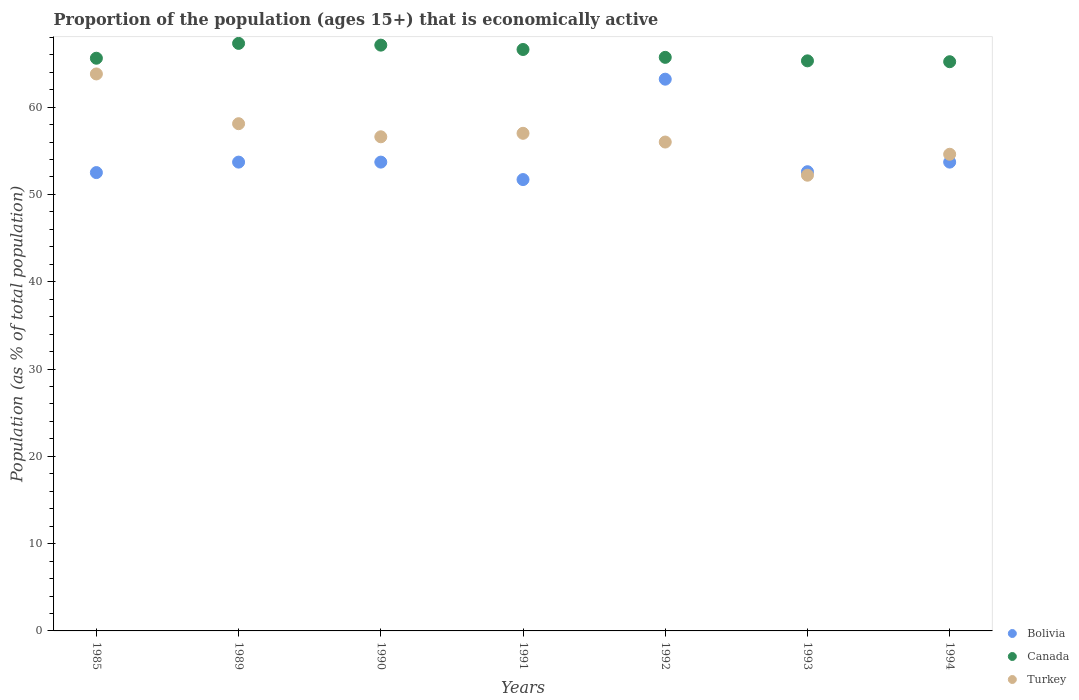Is the number of dotlines equal to the number of legend labels?
Offer a very short reply. Yes. What is the proportion of the population that is economically active in Bolivia in 1985?
Provide a short and direct response. 52.5. Across all years, what is the maximum proportion of the population that is economically active in Turkey?
Provide a short and direct response. 63.8. Across all years, what is the minimum proportion of the population that is economically active in Canada?
Your answer should be very brief. 65.2. In which year was the proportion of the population that is economically active in Canada maximum?
Provide a short and direct response. 1989. What is the total proportion of the population that is economically active in Canada in the graph?
Offer a terse response. 462.8. What is the difference between the proportion of the population that is economically active in Canada in 1985 and that in 1993?
Offer a very short reply. 0.3. What is the difference between the proportion of the population that is economically active in Canada in 1993 and the proportion of the population that is economically active in Turkey in 1985?
Your answer should be very brief. 1.5. What is the average proportion of the population that is economically active in Canada per year?
Your answer should be very brief. 66.11. In the year 1990, what is the difference between the proportion of the population that is economically active in Bolivia and proportion of the population that is economically active in Turkey?
Keep it short and to the point. -2.9. In how many years, is the proportion of the population that is economically active in Canada greater than 22 %?
Keep it short and to the point. 7. What is the ratio of the proportion of the population that is economically active in Turkey in 1992 to that in 1993?
Your response must be concise. 1.07. Is the proportion of the population that is economically active in Canada in 1989 less than that in 1991?
Make the answer very short. No. Is the difference between the proportion of the population that is economically active in Bolivia in 1991 and 1993 greater than the difference between the proportion of the population that is economically active in Turkey in 1991 and 1993?
Make the answer very short. No. What is the difference between the highest and the second highest proportion of the population that is economically active in Turkey?
Offer a terse response. 5.7. What is the difference between the highest and the lowest proportion of the population that is economically active in Turkey?
Offer a very short reply. 11.6. Is the proportion of the population that is economically active in Turkey strictly less than the proportion of the population that is economically active in Bolivia over the years?
Your answer should be compact. No. How many dotlines are there?
Offer a very short reply. 3. How many years are there in the graph?
Your answer should be compact. 7. What is the difference between two consecutive major ticks on the Y-axis?
Provide a short and direct response. 10. Are the values on the major ticks of Y-axis written in scientific E-notation?
Your answer should be compact. No. Does the graph contain grids?
Give a very brief answer. No. Where does the legend appear in the graph?
Your answer should be compact. Bottom right. How are the legend labels stacked?
Provide a short and direct response. Vertical. What is the title of the graph?
Offer a terse response. Proportion of the population (ages 15+) that is economically active. Does "Serbia" appear as one of the legend labels in the graph?
Offer a very short reply. No. What is the label or title of the X-axis?
Give a very brief answer. Years. What is the label or title of the Y-axis?
Keep it short and to the point. Population (as % of total population). What is the Population (as % of total population) of Bolivia in 1985?
Give a very brief answer. 52.5. What is the Population (as % of total population) in Canada in 1985?
Keep it short and to the point. 65.6. What is the Population (as % of total population) of Turkey in 1985?
Give a very brief answer. 63.8. What is the Population (as % of total population) in Bolivia in 1989?
Make the answer very short. 53.7. What is the Population (as % of total population) in Canada in 1989?
Give a very brief answer. 67.3. What is the Population (as % of total population) of Turkey in 1989?
Keep it short and to the point. 58.1. What is the Population (as % of total population) in Bolivia in 1990?
Your response must be concise. 53.7. What is the Population (as % of total population) in Canada in 1990?
Keep it short and to the point. 67.1. What is the Population (as % of total population) of Turkey in 1990?
Offer a terse response. 56.6. What is the Population (as % of total population) in Bolivia in 1991?
Offer a very short reply. 51.7. What is the Population (as % of total population) in Canada in 1991?
Ensure brevity in your answer.  66.6. What is the Population (as % of total population) of Turkey in 1991?
Provide a succinct answer. 57. What is the Population (as % of total population) in Bolivia in 1992?
Provide a succinct answer. 63.2. What is the Population (as % of total population) in Canada in 1992?
Give a very brief answer. 65.7. What is the Population (as % of total population) of Bolivia in 1993?
Provide a short and direct response. 52.6. What is the Population (as % of total population) of Canada in 1993?
Offer a terse response. 65.3. What is the Population (as % of total population) of Turkey in 1993?
Your answer should be compact. 52.2. What is the Population (as % of total population) of Bolivia in 1994?
Your answer should be very brief. 53.7. What is the Population (as % of total population) of Canada in 1994?
Offer a very short reply. 65.2. What is the Population (as % of total population) in Turkey in 1994?
Offer a very short reply. 54.6. Across all years, what is the maximum Population (as % of total population) of Bolivia?
Provide a succinct answer. 63.2. Across all years, what is the maximum Population (as % of total population) in Canada?
Offer a very short reply. 67.3. Across all years, what is the maximum Population (as % of total population) of Turkey?
Keep it short and to the point. 63.8. Across all years, what is the minimum Population (as % of total population) of Bolivia?
Make the answer very short. 51.7. Across all years, what is the minimum Population (as % of total population) of Canada?
Your answer should be compact. 65.2. Across all years, what is the minimum Population (as % of total population) in Turkey?
Keep it short and to the point. 52.2. What is the total Population (as % of total population) of Bolivia in the graph?
Make the answer very short. 381.1. What is the total Population (as % of total population) of Canada in the graph?
Your answer should be compact. 462.8. What is the total Population (as % of total population) in Turkey in the graph?
Your answer should be very brief. 398.3. What is the difference between the Population (as % of total population) in Turkey in 1985 and that in 1989?
Keep it short and to the point. 5.7. What is the difference between the Population (as % of total population) in Canada in 1985 and that in 1990?
Give a very brief answer. -1.5. What is the difference between the Population (as % of total population) in Canada in 1985 and that in 1991?
Your response must be concise. -1. What is the difference between the Population (as % of total population) of Bolivia in 1985 and that in 1992?
Offer a terse response. -10.7. What is the difference between the Population (as % of total population) in Canada in 1985 and that in 1992?
Your answer should be very brief. -0.1. What is the difference between the Population (as % of total population) in Canada in 1985 and that in 1993?
Your answer should be very brief. 0.3. What is the difference between the Population (as % of total population) of Bolivia in 1985 and that in 1994?
Keep it short and to the point. -1.2. What is the difference between the Population (as % of total population) in Turkey in 1989 and that in 1990?
Your answer should be very brief. 1.5. What is the difference between the Population (as % of total population) of Turkey in 1989 and that in 1991?
Your answer should be compact. 1.1. What is the difference between the Population (as % of total population) in Canada in 1989 and that in 1992?
Give a very brief answer. 1.6. What is the difference between the Population (as % of total population) of Canada in 1989 and that in 1993?
Your answer should be compact. 2. What is the difference between the Population (as % of total population) in Bolivia in 1989 and that in 1994?
Your response must be concise. 0. What is the difference between the Population (as % of total population) in Canada in 1990 and that in 1991?
Offer a very short reply. 0.5. What is the difference between the Population (as % of total population) in Turkey in 1990 and that in 1991?
Your answer should be very brief. -0.4. What is the difference between the Population (as % of total population) in Turkey in 1990 and that in 1992?
Offer a terse response. 0.6. What is the difference between the Population (as % of total population) of Turkey in 1990 and that in 1993?
Keep it short and to the point. 4.4. What is the difference between the Population (as % of total population) in Turkey in 1990 and that in 1994?
Give a very brief answer. 2. What is the difference between the Population (as % of total population) of Canada in 1991 and that in 1992?
Your response must be concise. 0.9. What is the difference between the Population (as % of total population) of Turkey in 1991 and that in 1992?
Your answer should be compact. 1. What is the difference between the Population (as % of total population) in Bolivia in 1991 and that in 1993?
Your answer should be very brief. -0.9. What is the difference between the Population (as % of total population) of Canada in 1991 and that in 1993?
Make the answer very short. 1.3. What is the difference between the Population (as % of total population) of Turkey in 1991 and that in 1993?
Your answer should be compact. 4.8. What is the difference between the Population (as % of total population) of Bolivia in 1991 and that in 1994?
Offer a very short reply. -2. What is the difference between the Population (as % of total population) in Canada in 1991 and that in 1994?
Keep it short and to the point. 1.4. What is the difference between the Population (as % of total population) of Canada in 1992 and that in 1993?
Your answer should be compact. 0.4. What is the difference between the Population (as % of total population) in Turkey in 1992 and that in 1994?
Provide a succinct answer. 1.4. What is the difference between the Population (as % of total population) of Turkey in 1993 and that in 1994?
Offer a terse response. -2.4. What is the difference between the Population (as % of total population) of Bolivia in 1985 and the Population (as % of total population) of Canada in 1989?
Provide a succinct answer. -14.8. What is the difference between the Population (as % of total population) of Bolivia in 1985 and the Population (as % of total population) of Canada in 1990?
Give a very brief answer. -14.6. What is the difference between the Population (as % of total population) of Canada in 1985 and the Population (as % of total population) of Turkey in 1990?
Make the answer very short. 9. What is the difference between the Population (as % of total population) in Bolivia in 1985 and the Population (as % of total population) in Canada in 1991?
Your answer should be very brief. -14.1. What is the difference between the Population (as % of total population) of Bolivia in 1985 and the Population (as % of total population) of Turkey in 1991?
Offer a terse response. -4.5. What is the difference between the Population (as % of total population) in Bolivia in 1985 and the Population (as % of total population) in Canada in 1992?
Make the answer very short. -13.2. What is the difference between the Population (as % of total population) of Canada in 1985 and the Population (as % of total population) of Turkey in 1992?
Ensure brevity in your answer.  9.6. What is the difference between the Population (as % of total population) of Canada in 1985 and the Population (as % of total population) of Turkey in 1993?
Make the answer very short. 13.4. What is the difference between the Population (as % of total population) of Bolivia in 1985 and the Population (as % of total population) of Canada in 1994?
Offer a terse response. -12.7. What is the difference between the Population (as % of total population) in Bolivia in 1985 and the Population (as % of total population) in Turkey in 1994?
Provide a short and direct response. -2.1. What is the difference between the Population (as % of total population) in Canada in 1985 and the Population (as % of total population) in Turkey in 1994?
Provide a succinct answer. 11. What is the difference between the Population (as % of total population) in Bolivia in 1989 and the Population (as % of total population) in Turkey in 1991?
Make the answer very short. -3.3. What is the difference between the Population (as % of total population) in Canada in 1989 and the Population (as % of total population) in Turkey in 1991?
Make the answer very short. 10.3. What is the difference between the Population (as % of total population) in Bolivia in 1989 and the Population (as % of total population) in Canada in 1992?
Make the answer very short. -12. What is the difference between the Population (as % of total population) of Canada in 1989 and the Population (as % of total population) of Turkey in 1992?
Your answer should be very brief. 11.3. What is the difference between the Population (as % of total population) in Bolivia in 1989 and the Population (as % of total population) in Canada in 1993?
Make the answer very short. -11.6. What is the difference between the Population (as % of total population) of Bolivia in 1989 and the Population (as % of total population) of Turkey in 1993?
Offer a terse response. 1.5. What is the difference between the Population (as % of total population) of Bolivia in 1989 and the Population (as % of total population) of Turkey in 1994?
Your answer should be compact. -0.9. What is the difference between the Population (as % of total population) of Canada in 1989 and the Population (as % of total population) of Turkey in 1994?
Ensure brevity in your answer.  12.7. What is the difference between the Population (as % of total population) of Bolivia in 1990 and the Population (as % of total population) of Canada in 1991?
Your response must be concise. -12.9. What is the difference between the Population (as % of total population) in Bolivia in 1990 and the Population (as % of total population) in Turkey in 1991?
Your answer should be compact. -3.3. What is the difference between the Population (as % of total population) of Bolivia in 1990 and the Population (as % of total population) of Canada in 1992?
Offer a very short reply. -12. What is the difference between the Population (as % of total population) in Bolivia in 1990 and the Population (as % of total population) in Turkey in 1992?
Keep it short and to the point. -2.3. What is the difference between the Population (as % of total population) of Canada in 1990 and the Population (as % of total population) of Turkey in 1992?
Offer a very short reply. 11.1. What is the difference between the Population (as % of total population) in Bolivia in 1990 and the Population (as % of total population) in Turkey in 1993?
Make the answer very short. 1.5. What is the difference between the Population (as % of total population) in Bolivia in 1990 and the Population (as % of total population) in Canada in 1994?
Ensure brevity in your answer.  -11.5. What is the difference between the Population (as % of total population) of Bolivia in 1990 and the Population (as % of total population) of Turkey in 1994?
Offer a very short reply. -0.9. What is the difference between the Population (as % of total population) in Bolivia in 1991 and the Population (as % of total population) in Canada in 1993?
Ensure brevity in your answer.  -13.6. What is the difference between the Population (as % of total population) in Canada in 1991 and the Population (as % of total population) in Turkey in 1993?
Make the answer very short. 14.4. What is the difference between the Population (as % of total population) in Bolivia in 1991 and the Population (as % of total population) in Canada in 1994?
Provide a succinct answer. -13.5. What is the difference between the Population (as % of total population) in Canada in 1991 and the Population (as % of total population) in Turkey in 1994?
Offer a terse response. 12. What is the difference between the Population (as % of total population) of Bolivia in 1992 and the Population (as % of total population) of Turkey in 1993?
Offer a terse response. 11. What is the difference between the Population (as % of total population) of Canada in 1992 and the Population (as % of total population) of Turkey in 1993?
Make the answer very short. 13.5. What is the difference between the Population (as % of total population) in Bolivia in 1992 and the Population (as % of total population) in Canada in 1994?
Offer a very short reply. -2. What is the difference between the Population (as % of total population) of Bolivia in 1992 and the Population (as % of total population) of Turkey in 1994?
Keep it short and to the point. 8.6. What is the difference between the Population (as % of total population) in Canada in 1992 and the Population (as % of total population) in Turkey in 1994?
Offer a very short reply. 11.1. What is the average Population (as % of total population) in Bolivia per year?
Provide a succinct answer. 54.44. What is the average Population (as % of total population) of Canada per year?
Offer a very short reply. 66.11. What is the average Population (as % of total population) in Turkey per year?
Make the answer very short. 56.9. In the year 1985, what is the difference between the Population (as % of total population) of Bolivia and Population (as % of total population) of Canada?
Provide a succinct answer. -13.1. In the year 1985, what is the difference between the Population (as % of total population) in Bolivia and Population (as % of total population) in Turkey?
Provide a succinct answer. -11.3. In the year 1985, what is the difference between the Population (as % of total population) of Canada and Population (as % of total population) of Turkey?
Your response must be concise. 1.8. In the year 1989, what is the difference between the Population (as % of total population) in Bolivia and Population (as % of total population) in Turkey?
Your answer should be very brief. -4.4. In the year 1990, what is the difference between the Population (as % of total population) of Bolivia and Population (as % of total population) of Canada?
Provide a succinct answer. -13.4. In the year 1990, what is the difference between the Population (as % of total population) in Bolivia and Population (as % of total population) in Turkey?
Keep it short and to the point. -2.9. In the year 1991, what is the difference between the Population (as % of total population) of Bolivia and Population (as % of total population) of Canada?
Offer a terse response. -14.9. In the year 1992, what is the difference between the Population (as % of total population) of Bolivia and Population (as % of total population) of Canada?
Keep it short and to the point. -2.5. In the year 1993, what is the difference between the Population (as % of total population) in Bolivia and Population (as % of total population) in Canada?
Provide a short and direct response. -12.7. In the year 1993, what is the difference between the Population (as % of total population) of Canada and Population (as % of total population) of Turkey?
Your answer should be very brief. 13.1. In the year 1994, what is the difference between the Population (as % of total population) in Bolivia and Population (as % of total population) in Canada?
Your answer should be very brief. -11.5. What is the ratio of the Population (as % of total population) of Bolivia in 1985 to that in 1989?
Your answer should be compact. 0.98. What is the ratio of the Population (as % of total population) in Canada in 1985 to that in 1989?
Provide a short and direct response. 0.97. What is the ratio of the Population (as % of total population) of Turkey in 1985 to that in 1989?
Keep it short and to the point. 1.1. What is the ratio of the Population (as % of total population) in Bolivia in 1985 to that in 1990?
Your answer should be compact. 0.98. What is the ratio of the Population (as % of total population) of Canada in 1985 to that in 1990?
Make the answer very short. 0.98. What is the ratio of the Population (as % of total population) in Turkey in 1985 to that in 1990?
Provide a short and direct response. 1.13. What is the ratio of the Population (as % of total population) in Bolivia in 1985 to that in 1991?
Keep it short and to the point. 1.02. What is the ratio of the Population (as % of total population) of Canada in 1985 to that in 1991?
Make the answer very short. 0.98. What is the ratio of the Population (as % of total population) in Turkey in 1985 to that in 1991?
Provide a short and direct response. 1.12. What is the ratio of the Population (as % of total population) in Bolivia in 1985 to that in 1992?
Give a very brief answer. 0.83. What is the ratio of the Population (as % of total population) of Turkey in 1985 to that in 1992?
Offer a very short reply. 1.14. What is the ratio of the Population (as % of total population) in Bolivia in 1985 to that in 1993?
Your response must be concise. 1. What is the ratio of the Population (as % of total population) in Turkey in 1985 to that in 1993?
Provide a succinct answer. 1.22. What is the ratio of the Population (as % of total population) in Bolivia in 1985 to that in 1994?
Give a very brief answer. 0.98. What is the ratio of the Population (as % of total population) of Turkey in 1985 to that in 1994?
Offer a very short reply. 1.17. What is the ratio of the Population (as % of total population) of Bolivia in 1989 to that in 1990?
Offer a terse response. 1. What is the ratio of the Population (as % of total population) of Canada in 1989 to that in 1990?
Ensure brevity in your answer.  1. What is the ratio of the Population (as % of total population) in Turkey in 1989 to that in 1990?
Your response must be concise. 1.03. What is the ratio of the Population (as % of total population) in Bolivia in 1989 to that in 1991?
Ensure brevity in your answer.  1.04. What is the ratio of the Population (as % of total population) of Canada in 1989 to that in 1991?
Your response must be concise. 1.01. What is the ratio of the Population (as % of total population) in Turkey in 1989 to that in 1991?
Provide a short and direct response. 1.02. What is the ratio of the Population (as % of total population) in Bolivia in 1989 to that in 1992?
Your response must be concise. 0.85. What is the ratio of the Population (as % of total population) in Canada in 1989 to that in 1992?
Ensure brevity in your answer.  1.02. What is the ratio of the Population (as % of total population) in Turkey in 1989 to that in 1992?
Your answer should be compact. 1.04. What is the ratio of the Population (as % of total population) of Bolivia in 1989 to that in 1993?
Your answer should be very brief. 1.02. What is the ratio of the Population (as % of total population) in Canada in 1989 to that in 1993?
Your response must be concise. 1.03. What is the ratio of the Population (as % of total population) of Turkey in 1989 to that in 1993?
Offer a terse response. 1.11. What is the ratio of the Population (as % of total population) in Bolivia in 1989 to that in 1994?
Your answer should be compact. 1. What is the ratio of the Population (as % of total population) in Canada in 1989 to that in 1994?
Your response must be concise. 1.03. What is the ratio of the Population (as % of total population) in Turkey in 1989 to that in 1994?
Your response must be concise. 1.06. What is the ratio of the Population (as % of total population) in Bolivia in 1990 to that in 1991?
Offer a terse response. 1.04. What is the ratio of the Population (as % of total population) in Canada in 1990 to that in 1991?
Provide a short and direct response. 1.01. What is the ratio of the Population (as % of total population) of Turkey in 1990 to that in 1991?
Keep it short and to the point. 0.99. What is the ratio of the Population (as % of total population) in Bolivia in 1990 to that in 1992?
Your answer should be compact. 0.85. What is the ratio of the Population (as % of total population) of Canada in 1990 to that in 1992?
Your answer should be very brief. 1.02. What is the ratio of the Population (as % of total population) in Turkey in 1990 to that in 1992?
Your answer should be very brief. 1.01. What is the ratio of the Population (as % of total population) in Bolivia in 1990 to that in 1993?
Your answer should be compact. 1.02. What is the ratio of the Population (as % of total population) of Canada in 1990 to that in 1993?
Provide a succinct answer. 1.03. What is the ratio of the Population (as % of total population) in Turkey in 1990 to that in 1993?
Offer a terse response. 1.08. What is the ratio of the Population (as % of total population) of Bolivia in 1990 to that in 1994?
Offer a terse response. 1. What is the ratio of the Population (as % of total population) of Canada in 1990 to that in 1994?
Make the answer very short. 1.03. What is the ratio of the Population (as % of total population) of Turkey in 1990 to that in 1994?
Provide a short and direct response. 1.04. What is the ratio of the Population (as % of total population) in Bolivia in 1991 to that in 1992?
Keep it short and to the point. 0.82. What is the ratio of the Population (as % of total population) in Canada in 1991 to that in 1992?
Provide a short and direct response. 1.01. What is the ratio of the Population (as % of total population) of Turkey in 1991 to that in 1992?
Offer a very short reply. 1.02. What is the ratio of the Population (as % of total population) of Bolivia in 1991 to that in 1993?
Make the answer very short. 0.98. What is the ratio of the Population (as % of total population) in Canada in 1991 to that in 1993?
Keep it short and to the point. 1.02. What is the ratio of the Population (as % of total population) of Turkey in 1991 to that in 1993?
Offer a very short reply. 1.09. What is the ratio of the Population (as % of total population) in Bolivia in 1991 to that in 1994?
Offer a terse response. 0.96. What is the ratio of the Population (as % of total population) in Canada in 1991 to that in 1994?
Make the answer very short. 1.02. What is the ratio of the Population (as % of total population) in Turkey in 1991 to that in 1994?
Offer a very short reply. 1.04. What is the ratio of the Population (as % of total population) of Bolivia in 1992 to that in 1993?
Provide a succinct answer. 1.2. What is the ratio of the Population (as % of total population) of Canada in 1992 to that in 1993?
Your response must be concise. 1.01. What is the ratio of the Population (as % of total population) in Turkey in 1992 to that in 1993?
Keep it short and to the point. 1.07. What is the ratio of the Population (as % of total population) of Bolivia in 1992 to that in 1994?
Your answer should be compact. 1.18. What is the ratio of the Population (as % of total population) in Canada in 1992 to that in 1994?
Ensure brevity in your answer.  1.01. What is the ratio of the Population (as % of total population) in Turkey in 1992 to that in 1994?
Ensure brevity in your answer.  1.03. What is the ratio of the Population (as % of total population) of Bolivia in 1993 to that in 1994?
Provide a short and direct response. 0.98. What is the ratio of the Population (as % of total population) of Canada in 1993 to that in 1994?
Provide a succinct answer. 1. What is the ratio of the Population (as % of total population) in Turkey in 1993 to that in 1994?
Give a very brief answer. 0.96. What is the difference between the highest and the second highest Population (as % of total population) in Turkey?
Ensure brevity in your answer.  5.7. What is the difference between the highest and the lowest Population (as % of total population) in Bolivia?
Keep it short and to the point. 11.5. What is the difference between the highest and the lowest Population (as % of total population) in Canada?
Keep it short and to the point. 2.1. 